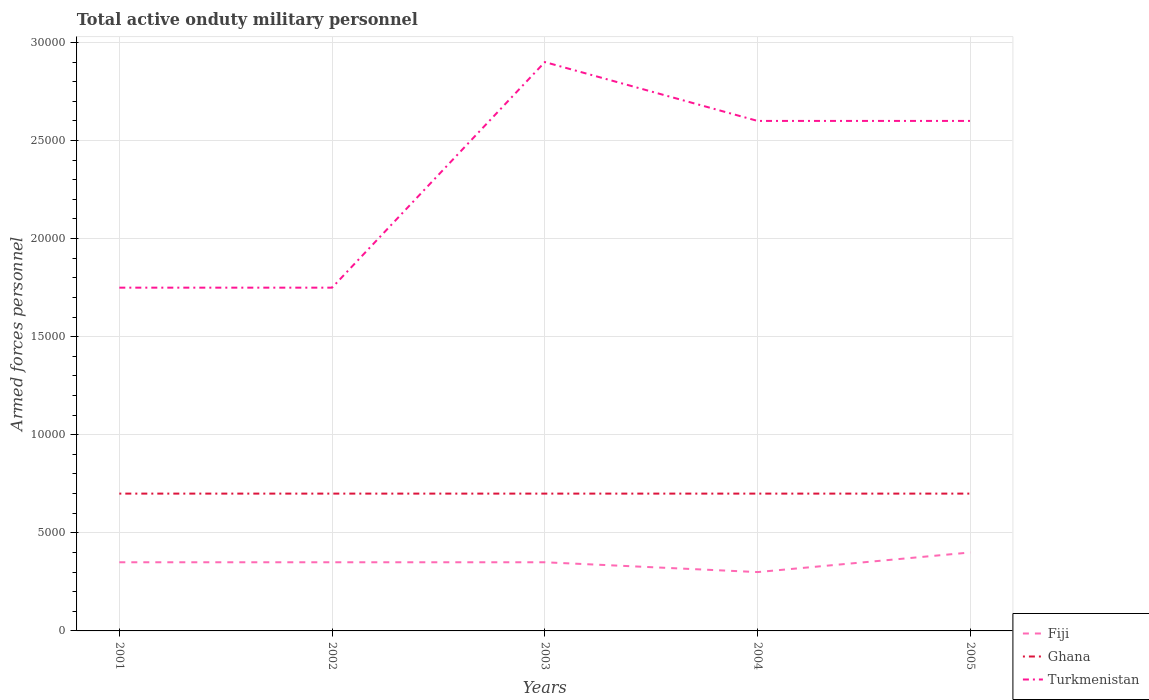Does the line corresponding to Turkmenistan intersect with the line corresponding to Fiji?
Ensure brevity in your answer.  No. Across all years, what is the maximum number of armed forces personnel in Turkmenistan?
Offer a very short reply. 1.75e+04. In which year was the number of armed forces personnel in Ghana maximum?
Provide a short and direct response. 2001. What is the total number of armed forces personnel in Turkmenistan in the graph?
Offer a terse response. 0. What is the difference between the highest and the second highest number of armed forces personnel in Turkmenistan?
Offer a terse response. 1.15e+04. What is the difference between the highest and the lowest number of armed forces personnel in Turkmenistan?
Your answer should be compact. 3. Is the number of armed forces personnel in Turkmenistan strictly greater than the number of armed forces personnel in Ghana over the years?
Keep it short and to the point. No. How many lines are there?
Provide a short and direct response. 3. How many legend labels are there?
Provide a succinct answer. 3. How are the legend labels stacked?
Provide a short and direct response. Vertical. What is the title of the graph?
Provide a short and direct response. Total active onduty military personnel. Does "Ghana" appear as one of the legend labels in the graph?
Offer a very short reply. Yes. What is the label or title of the Y-axis?
Your answer should be compact. Armed forces personnel. What is the Armed forces personnel of Fiji in 2001?
Offer a very short reply. 3500. What is the Armed forces personnel of Ghana in 2001?
Offer a very short reply. 7000. What is the Armed forces personnel in Turkmenistan in 2001?
Ensure brevity in your answer.  1.75e+04. What is the Armed forces personnel in Fiji in 2002?
Make the answer very short. 3500. What is the Armed forces personnel of Ghana in 2002?
Your response must be concise. 7000. What is the Armed forces personnel in Turkmenistan in 2002?
Provide a succinct answer. 1.75e+04. What is the Armed forces personnel of Fiji in 2003?
Your answer should be compact. 3500. What is the Armed forces personnel in Ghana in 2003?
Give a very brief answer. 7000. What is the Armed forces personnel in Turkmenistan in 2003?
Offer a very short reply. 2.90e+04. What is the Armed forces personnel in Fiji in 2004?
Give a very brief answer. 3000. What is the Armed forces personnel in Ghana in 2004?
Your response must be concise. 7000. What is the Armed forces personnel in Turkmenistan in 2004?
Offer a very short reply. 2.60e+04. What is the Armed forces personnel of Fiji in 2005?
Give a very brief answer. 4000. What is the Armed forces personnel of Ghana in 2005?
Offer a very short reply. 7000. What is the Armed forces personnel of Turkmenistan in 2005?
Your answer should be very brief. 2.60e+04. Across all years, what is the maximum Armed forces personnel of Fiji?
Give a very brief answer. 4000. Across all years, what is the maximum Armed forces personnel in Ghana?
Make the answer very short. 7000. Across all years, what is the maximum Armed forces personnel of Turkmenistan?
Keep it short and to the point. 2.90e+04. Across all years, what is the minimum Armed forces personnel of Fiji?
Your response must be concise. 3000. Across all years, what is the minimum Armed forces personnel of Ghana?
Make the answer very short. 7000. Across all years, what is the minimum Armed forces personnel of Turkmenistan?
Provide a short and direct response. 1.75e+04. What is the total Armed forces personnel of Fiji in the graph?
Your answer should be very brief. 1.75e+04. What is the total Armed forces personnel of Ghana in the graph?
Offer a very short reply. 3.50e+04. What is the total Armed forces personnel in Turkmenistan in the graph?
Ensure brevity in your answer.  1.16e+05. What is the difference between the Armed forces personnel in Fiji in 2001 and that in 2002?
Provide a succinct answer. 0. What is the difference between the Armed forces personnel of Ghana in 2001 and that in 2002?
Your answer should be very brief. 0. What is the difference between the Armed forces personnel in Turkmenistan in 2001 and that in 2002?
Give a very brief answer. 0. What is the difference between the Armed forces personnel in Fiji in 2001 and that in 2003?
Offer a very short reply. 0. What is the difference between the Armed forces personnel in Turkmenistan in 2001 and that in 2003?
Your response must be concise. -1.15e+04. What is the difference between the Armed forces personnel of Turkmenistan in 2001 and that in 2004?
Make the answer very short. -8500. What is the difference between the Armed forces personnel in Fiji in 2001 and that in 2005?
Make the answer very short. -500. What is the difference between the Armed forces personnel in Turkmenistan in 2001 and that in 2005?
Your answer should be compact. -8500. What is the difference between the Armed forces personnel in Ghana in 2002 and that in 2003?
Ensure brevity in your answer.  0. What is the difference between the Armed forces personnel in Turkmenistan in 2002 and that in 2003?
Your answer should be compact. -1.15e+04. What is the difference between the Armed forces personnel of Turkmenistan in 2002 and that in 2004?
Provide a succinct answer. -8500. What is the difference between the Armed forces personnel in Fiji in 2002 and that in 2005?
Make the answer very short. -500. What is the difference between the Armed forces personnel of Ghana in 2002 and that in 2005?
Offer a very short reply. 0. What is the difference between the Armed forces personnel of Turkmenistan in 2002 and that in 2005?
Offer a very short reply. -8500. What is the difference between the Armed forces personnel in Fiji in 2003 and that in 2004?
Make the answer very short. 500. What is the difference between the Armed forces personnel in Turkmenistan in 2003 and that in 2004?
Your answer should be very brief. 3000. What is the difference between the Armed forces personnel in Fiji in 2003 and that in 2005?
Keep it short and to the point. -500. What is the difference between the Armed forces personnel in Turkmenistan in 2003 and that in 2005?
Keep it short and to the point. 3000. What is the difference between the Armed forces personnel in Fiji in 2004 and that in 2005?
Offer a very short reply. -1000. What is the difference between the Armed forces personnel of Ghana in 2004 and that in 2005?
Provide a short and direct response. 0. What is the difference between the Armed forces personnel of Turkmenistan in 2004 and that in 2005?
Provide a short and direct response. 0. What is the difference between the Armed forces personnel in Fiji in 2001 and the Armed forces personnel in Ghana in 2002?
Give a very brief answer. -3500. What is the difference between the Armed forces personnel in Fiji in 2001 and the Armed forces personnel in Turkmenistan in 2002?
Offer a terse response. -1.40e+04. What is the difference between the Armed forces personnel in Ghana in 2001 and the Armed forces personnel in Turkmenistan in 2002?
Give a very brief answer. -1.05e+04. What is the difference between the Armed forces personnel in Fiji in 2001 and the Armed forces personnel in Ghana in 2003?
Offer a very short reply. -3500. What is the difference between the Armed forces personnel of Fiji in 2001 and the Armed forces personnel of Turkmenistan in 2003?
Your response must be concise. -2.55e+04. What is the difference between the Armed forces personnel in Ghana in 2001 and the Armed forces personnel in Turkmenistan in 2003?
Provide a short and direct response. -2.20e+04. What is the difference between the Armed forces personnel of Fiji in 2001 and the Armed forces personnel of Ghana in 2004?
Your answer should be compact. -3500. What is the difference between the Armed forces personnel of Fiji in 2001 and the Armed forces personnel of Turkmenistan in 2004?
Give a very brief answer. -2.25e+04. What is the difference between the Armed forces personnel of Ghana in 2001 and the Armed forces personnel of Turkmenistan in 2004?
Make the answer very short. -1.90e+04. What is the difference between the Armed forces personnel of Fiji in 2001 and the Armed forces personnel of Ghana in 2005?
Provide a short and direct response. -3500. What is the difference between the Armed forces personnel of Fiji in 2001 and the Armed forces personnel of Turkmenistan in 2005?
Give a very brief answer. -2.25e+04. What is the difference between the Armed forces personnel in Ghana in 2001 and the Armed forces personnel in Turkmenistan in 2005?
Offer a terse response. -1.90e+04. What is the difference between the Armed forces personnel of Fiji in 2002 and the Armed forces personnel of Ghana in 2003?
Offer a terse response. -3500. What is the difference between the Armed forces personnel in Fiji in 2002 and the Armed forces personnel in Turkmenistan in 2003?
Provide a succinct answer. -2.55e+04. What is the difference between the Armed forces personnel of Ghana in 2002 and the Armed forces personnel of Turkmenistan in 2003?
Offer a terse response. -2.20e+04. What is the difference between the Armed forces personnel of Fiji in 2002 and the Armed forces personnel of Ghana in 2004?
Keep it short and to the point. -3500. What is the difference between the Armed forces personnel in Fiji in 2002 and the Armed forces personnel in Turkmenistan in 2004?
Keep it short and to the point. -2.25e+04. What is the difference between the Armed forces personnel of Ghana in 2002 and the Armed forces personnel of Turkmenistan in 2004?
Offer a very short reply. -1.90e+04. What is the difference between the Armed forces personnel of Fiji in 2002 and the Armed forces personnel of Ghana in 2005?
Offer a terse response. -3500. What is the difference between the Armed forces personnel of Fiji in 2002 and the Armed forces personnel of Turkmenistan in 2005?
Your answer should be very brief. -2.25e+04. What is the difference between the Armed forces personnel in Ghana in 2002 and the Armed forces personnel in Turkmenistan in 2005?
Ensure brevity in your answer.  -1.90e+04. What is the difference between the Armed forces personnel of Fiji in 2003 and the Armed forces personnel of Ghana in 2004?
Offer a very short reply. -3500. What is the difference between the Armed forces personnel of Fiji in 2003 and the Armed forces personnel of Turkmenistan in 2004?
Your answer should be very brief. -2.25e+04. What is the difference between the Armed forces personnel in Ghana in 2003 and the Armed forces personnel in Turkmenistan in 2004?
Provide a succinct answer. -1.90e+04. What is the difference between the Armed forces personnel in Fiji in 2003 and the Armed forces personnel in Ghana in 2005?
Provide a short and direct response. -3500. What is the difference between the Armed forces personnel in Fiji in 2003 and the Armed forces personnel in Turkmenistan in 2005?
Make the answer very short. -2.25e+04. What is the difference between the Armed forces personnel in Ghana in 2003 and the Armed forces personnel in Turkmenistan in 2005?
Your response must be concise. -1.90e+04. What is the difference between the Armed forces personnel in Fiji in 2004 and the Armed forces personnel in Ghana in 2005?
Ensure brevity in your answer.  -4000. What is the difference between the Armed forces personnel in Fiji in 2004 and the Armed forces personnel in Turkmenistan in 2005?
Your answer should be compact. -2.30e+04. What is the difference between the Armed forces personnel of Ghana in 2004 and the Armed forces personnel of Turkmenistan in 2005?
Keep it short and to the point. -1.90e+04. What is the average Armed forces personnel in Fiji per year?
Ensure brevity in your answer.  3500. What is the average Armed forces personnel of Ghana per year?
Offer a terse response. 7000. What is the average Armed forces personnel of Turkmenistan per year?
Your answer should be compact. 2.32e+04. In the year 2001, what is the difference between the Armed forces personnel in Fiji and Armed forces personnel in Ghana?
Offer a very short reply. -3500. In the year 2001, what is the difference between the Armed forces personnel in Fiji and Armed forces personnel in Turkmenistan?
Your answer should be compact. -1.40e+04. In the year 2001, what is the difference between the Armed forces personnel in Ghana and Armed forces personnel in Turkmenistan?
Give a very brief answer. -1.05e+04. In the year 2002, what is the difference between the Armed forces personnel of Fiji and Armed forces personnel of Ghana?
Offer a terse response. -3500. In the year 2002, what is the difference between the Armed forces personnel of Fiji and Armed forces personnel of Turkmenistan?
Offer a terse response. -1.40e+04. In the year 2002, what is the difference between the Armed forces personnel in Ghana and Armed forces personnel in Turkmenistan?
Offer a terse response. -1.05e+04. In the year 2003, what is the difference between the Armed forces personnel in Fiji and Armed forces personnel in Ghana?
Ensure brevity in your answer.  -3500. In the year 2003, what is the difference between the Armed forces personnel in Fiji and Armed forces personnel in Turkmenistan?
Provide a succinct answer. -2.55e+04. In the year 2003, what is the difference between the Armed forces personnel in Ghana and Armed forces personnel in Turkmenistan?
Offer a very short reply. -2.20e+04. In the year 2004, what is the difference between the Armed forces personnel of Fiji and Armed forces personnel of Ghana?
Your answer should be compact. -4000. In the year 2004, what is the difference between the Armed forces personnel of Fiji and Armed forces personnel of Turkmenistan?
Your answer should be compact. -2.30e+04. In the year 2004, what is the difference between the Armed forces personnel in Ghana and Armed forces personnel in Turkmenistan?
Make the answer very short. -1.90e+04. In the year 2005, what is the difference between the Armed forces personnel of Fiji and Armed forces personnel of Ghana?
Offer a terse response. -3000. In the year 2005, what is the difference between the Armed forces personnel in Fiji and Armed forces personnel in Turkmenistan?
Give a very brief answer. -2.20e+04. In the year 2005, what is the difference between the Armed forces personnel in Ghana and Armed forces personnel in Turkmenistan?
Give a very brief answer. -1.90e+04. What is the ratio of the Armed forces personnel in Ghana in 2001 to that in 2002?
Your response must be concise. 1. What is the ratio of the Armed forces personnel in Turkmenistan in 2001 to that in 2003?
Provide a short and direct response. 0.6. What is the ratio of the Armed forces personnel of Fiji in 2001 to that in 2004?
Ensure brevity in your answer.  1.17. What is the ratio of the Armed forces personnel of Turkmenistan in 2001 to that in 2004?
Ensure brevity in your answer.  0.67. What is the ratio of the Armed forces personnel in Turkmenistan in 2001 to that in 2005?
Give a very brief answer. 0.67. What is the ratio of the Armed forces personnel of Fiji in 2002 to that in 2003?
Ensure brevity in your answer.  1. What is the ratio of the Armed forces personnel of Ghana in 2002 to that in 2003?
Offer a terse response. 1. What is the ratio of the Armed forces personnel in Turkmenistan in 2002 to that in 2003?
Your answer should be compact. 0.6. What is the ratio of the Armed forces personnel of Turkmenistan in 2002 to that in 2004?
Make the answer very short. 0.67. What is the ratio of the Armed forces personnel in Fiji in 2002 to that in 2005?
Ensure brevity in your answer.  0.88. What is the ratio of the Armed forces personnel in Ghana in 2002 to that in 2005?
Ensure brevity in your answer.  1. What is the ratio of the Armed forces personnel in Turkmenistan in 2002 to that in 2005?
Ensure brevity in your answer.  0.67. What is the ratio of the Armed forces personnel in Fiji in 2003 to that in 2004?
Keep it short and to the point. 1.17. What is the ratio of the Armed forces personnel in Turkmenistan in 2003 to that in 2004?
Your answer should be compact. 1.12. What is the ratio of the Armed forces personnel in Ghana in 2003 to that in 2005?
Offer a terse response. 1. What is the ratio of the Armed forces personnel of Turkmenistan in 2003 to that in 2005?
Give a very brief answer. 1.12. What is the ratio of the Armed forces personnel of Turkmenistan in 2004 to that in 2005?
Make the answer very short. 1. What is the difference between the highest and the second highest Armed forces personnel in Fiji?
Offer a very short reply. 500. What is the difference between the highest and the second highest Armed forces personnel of Turkmenistan?
Give a very brief answer. 3000. What is the difference between the highest and the lowest Armed forces personnel in Fiji?
Your response must be concise. 1000. What is the difference between the highest and the lowest Armed forces personnel in Turkmenistan?
Your response must be concise. 1.15e+04. 